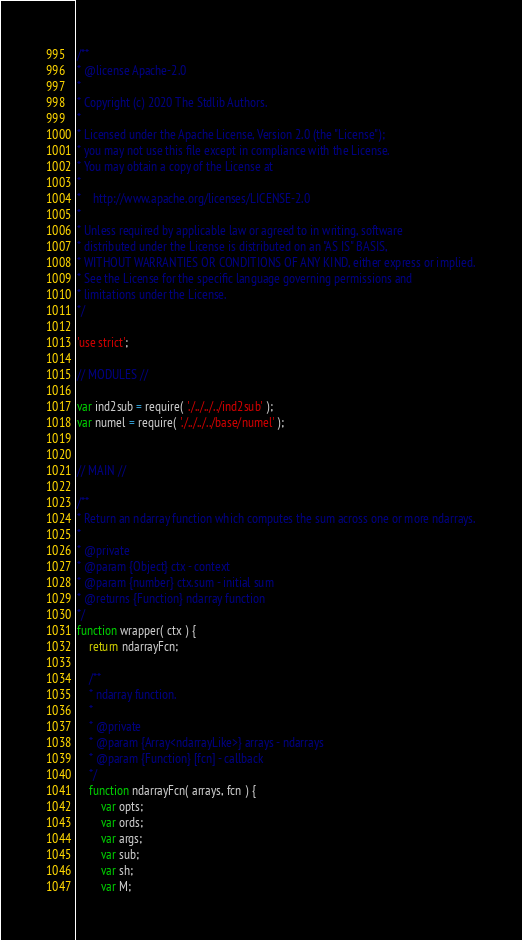<code> <loc_0><loc_0><loc_500><loc_500><_JavaScript_>/**
* @license Apache-2.0
*
* Copyright (c) 2020 The Stdlib Authors.
*
* Licensed under the Apache License, Version 2.0 (the "License");
* you may not use this file except in compliance with the License.
* You may obtain a copy of the License at
*
*    http://www.apache.org/licenses/LICENSE-2.0
*
* Unless required by applicable law or agreed to in writing, software
* distributed under the License is distributed on an "AS IS" BASIS,
* WITHOUT WARRANTIES OR CONDITIONS OF ANY KIND, either express or implied.
* See the License for the specific language governing permissions and
* limitations under the License.
*/

'use strict';

// MODULES //

var ind2sub = require( './../../../ind2sub' );
var numel = require( './../../../base/numel' );


// MAIN //

/**
* Return an ndarray function which computes the sum across one or more ndarrays.
*
* @private
* @param {Object} ctx - context
* @param {number} ctx.sum - initial sum
* @returns {Function} ndarray function
*/
function wrapper( ctx ) {
	return ndarrayFcn;

	/**
	* ndarray function.
	*
	* @private
	* @param {Array<ndarrayLike>} arrays - ndarrays
	* @param {Function} [fcn] - callback
	*/
	function ndarrayFcn( arrays, fcn ) {
		var opts;
		var ords;
		var args;
		var sub;
		var sh;
		var M;</code> 